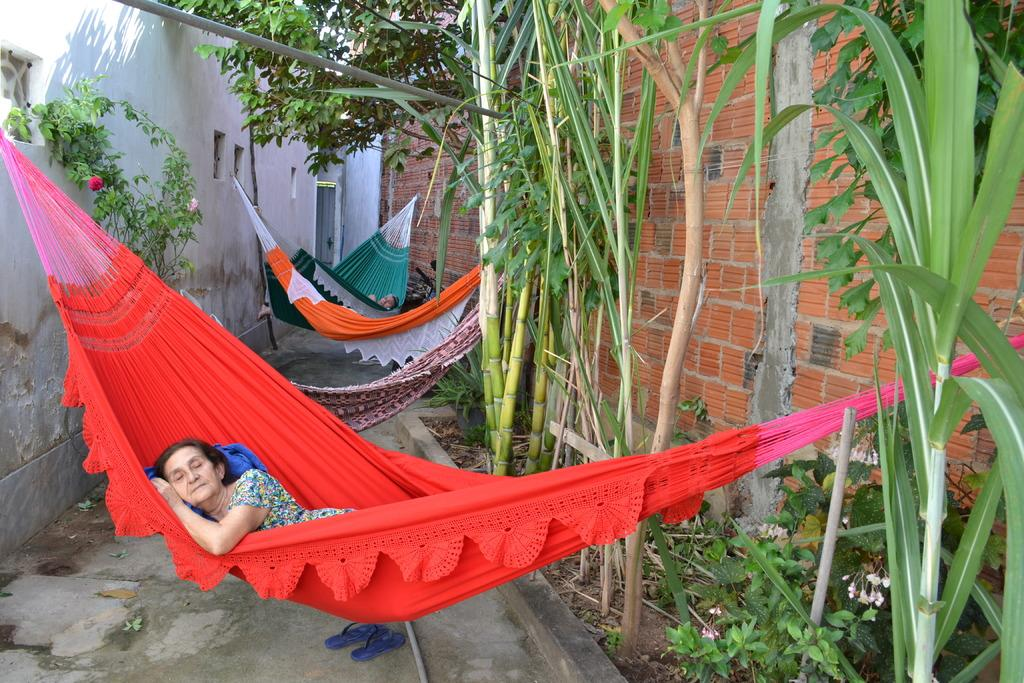What can be seen in the image that people might use for recreation? There are swings in the image that people might use for recreation. Can you describe the people in the image? There are people in the image, but their specific actions or appearances are not mentioned in the provided facts. What is on the ground in the image? There is footwear on the ground in the image. What can be seen in the distance in the image? There are houses, trees, and flowers in the background of the image. What type of plough is being used to cultivate the flowers in the image? There is no plough present in the image, and the flowers are not being cultivated. 